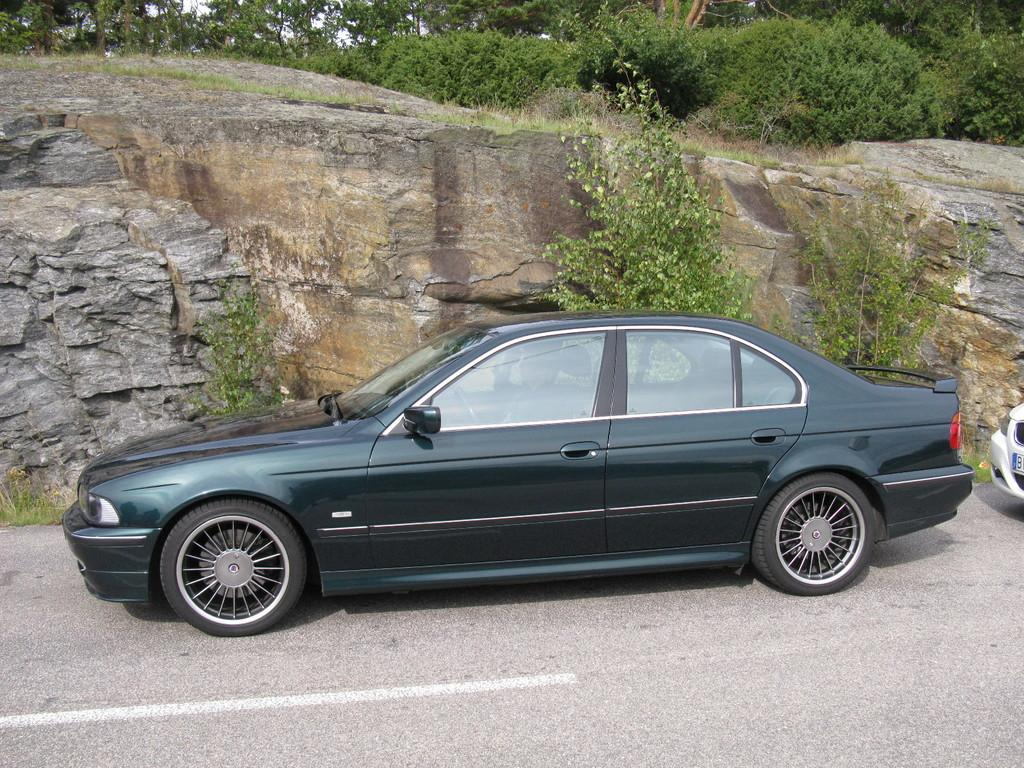What is located in the front of the image? There are vehicles in the front of the image. What can be seen in the background of the image? There is a rock wall, plants, and trees in the background of the image. What type of vegetation is visible in the background? There are plants and trees in the background of the image. What type of canvas is being used to support the field in the image? There is no canvas or field present in the image. What type of support is being used for the canvas in the image? There is no canvas or support present in the image. 